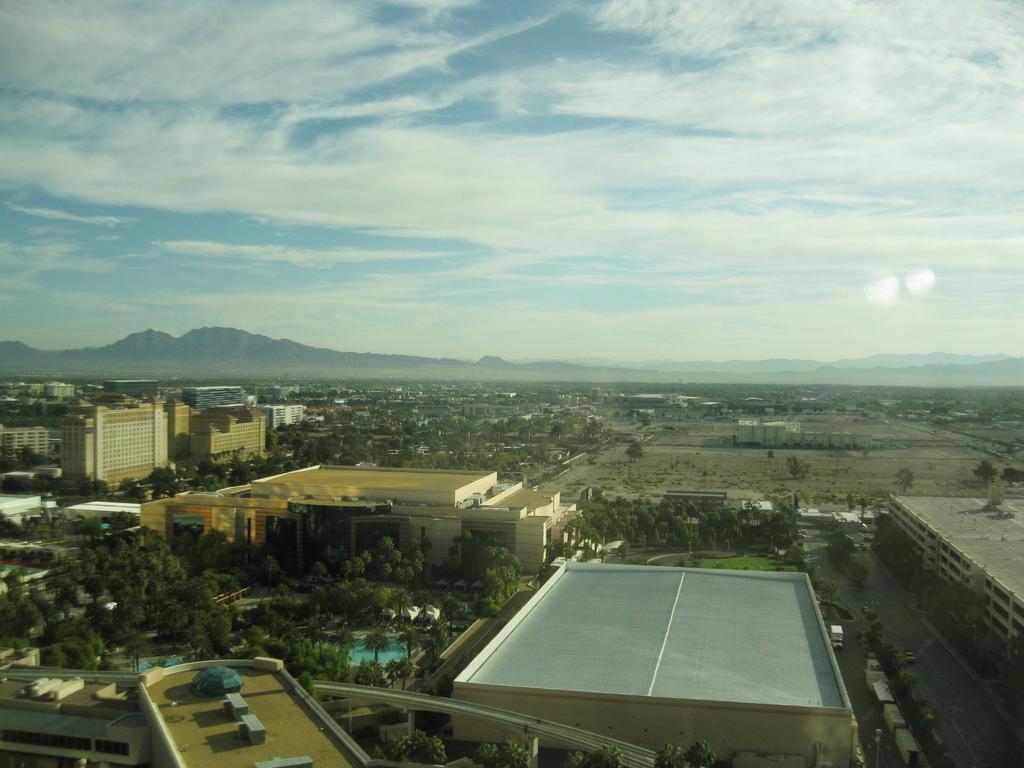Could you give a brief overview of what you see in this image? In this image, there are a few buildings, trees. We can see the ground with some objects. There are a few vehicles, hills. We can also see some grass and the sky with clouds. 